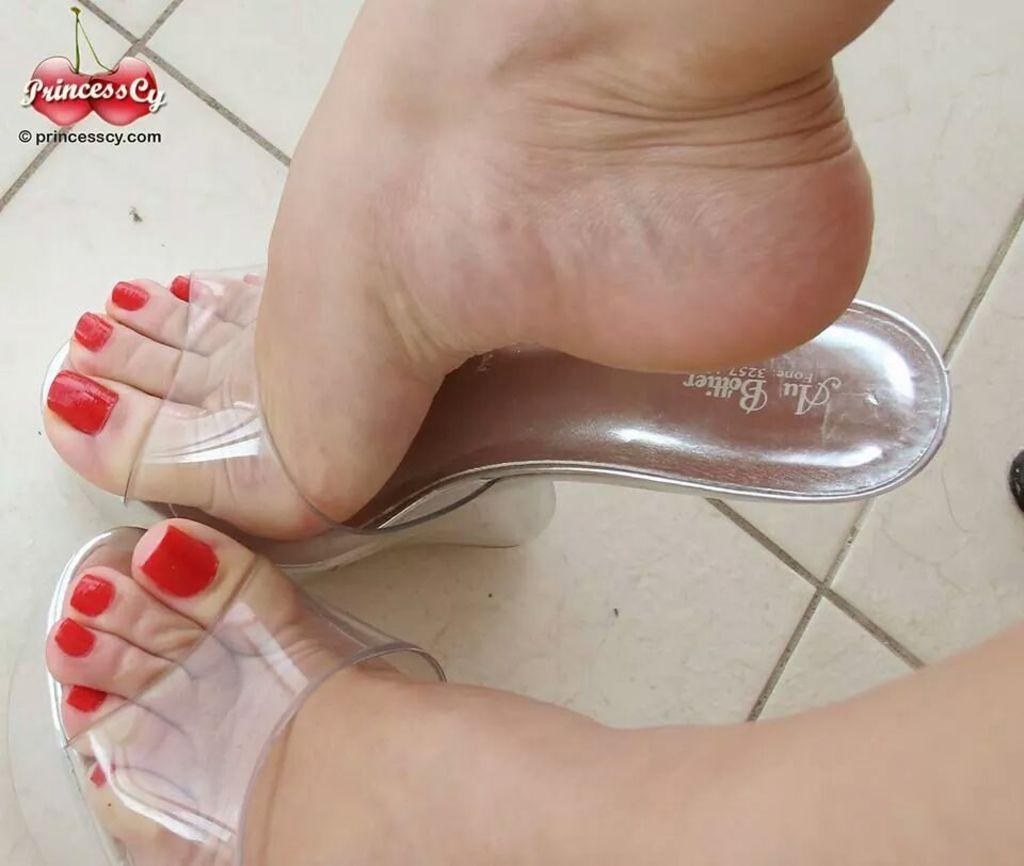Describe this image in one or two sentences. Here we can see person's legs wore footwear on the surface and left top of the image we can see logo. 